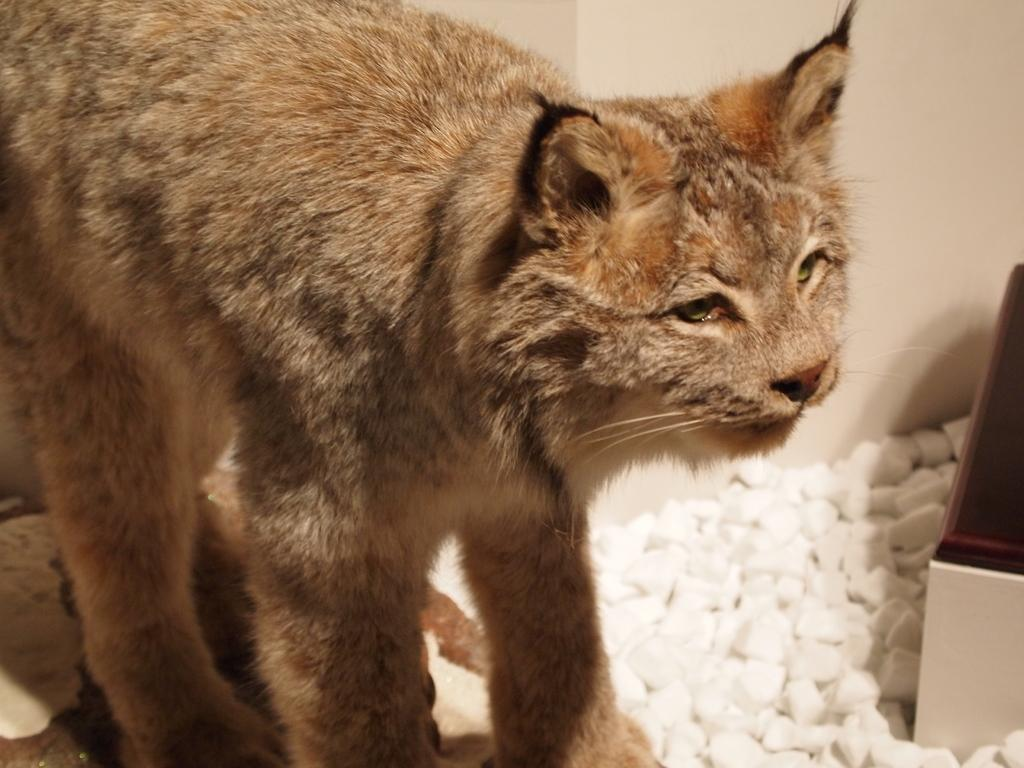What type of animal can be seen in the image? There is a cat in the image. What can be found at the right side of the image? There are many stones at the right side of the image, and there is also an object present. How many gold lizards are wishing for a treat in the image? There are no gold lizards or wishes present in the image; it features a cat and stones. 